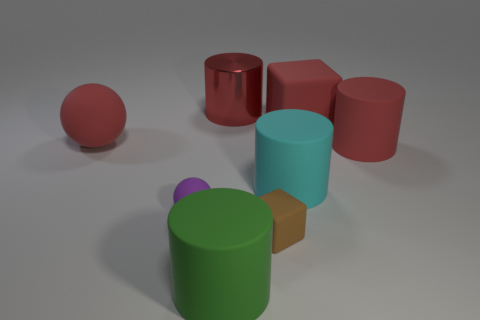Subtract 1 cylinders. How many cylinders are left? 3 Add 2 cyan cylinders. How many objects exist? 10 Subtract all spheres. How many objects are left? 6 Subtract all yellow balls. Subtract all cylinders. How many objects are left? 4 Add 4 cyan matte cylinders. How many cyan matte cylinders are left? 5 Add 7 large red spheres. How many large red spheres exist? 8 Subtract 0 brown cylinders. How many objects are left? 8 